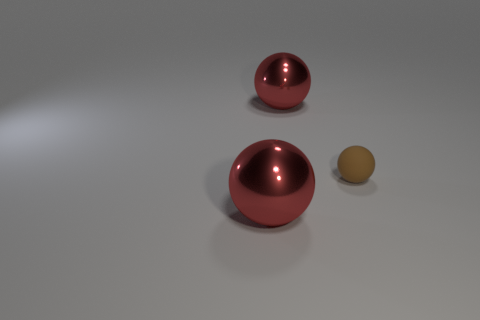Add 1 small blue shiny cubes. How many objects exist? 4 Subtract 1 brown balls. How many objects are left? 2 Subtract all cyan things. Subtract all red spheres. How many objects are left? 1 Add 1 tiny matte things. How many tiny matte things are left? 2 Add 2 tiny gray matte spheres. How many tiny gray matte spheres exist? 2 